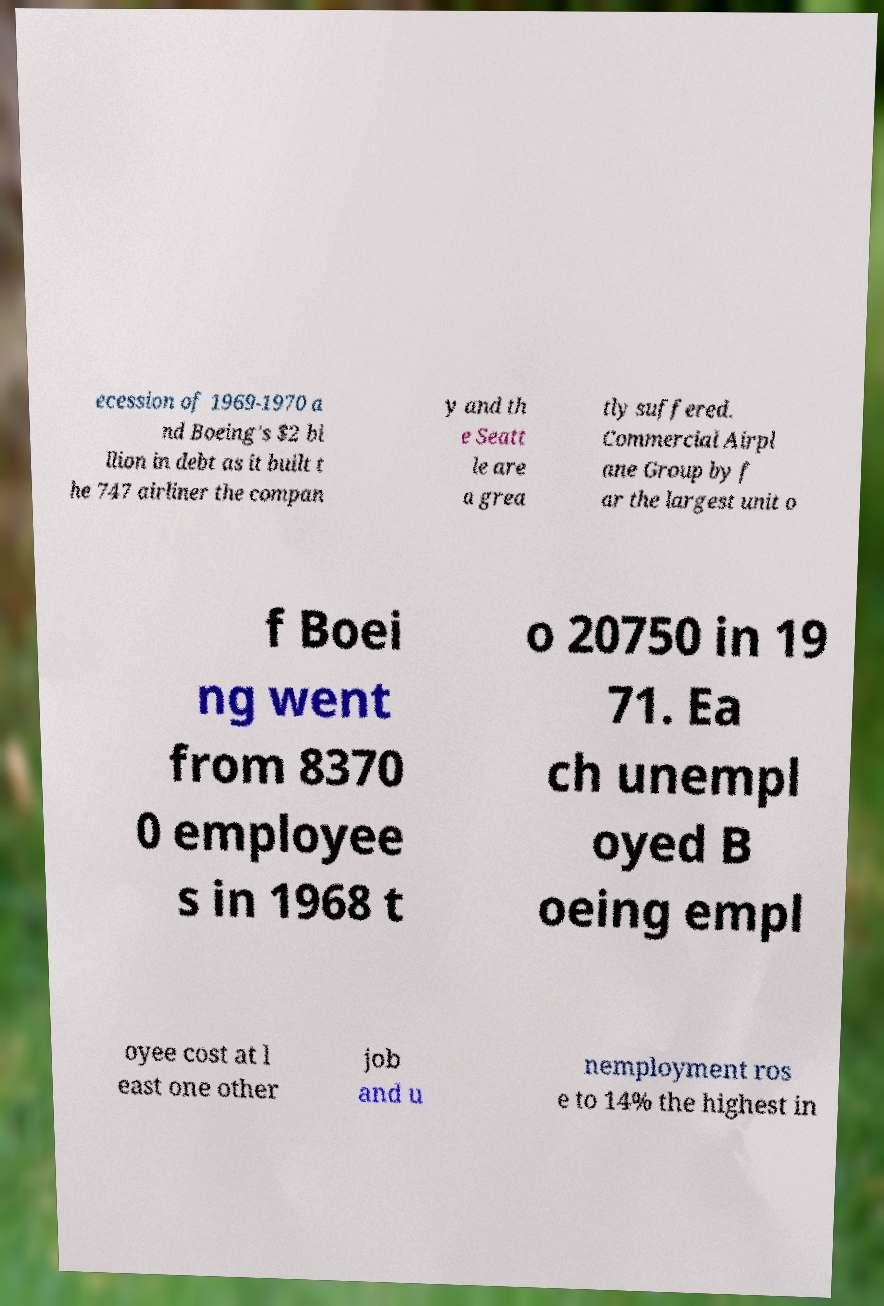Can you read and provide the text displayed in the image?This photo seems to have some interesting text. Can you extract and type it out for me? ecession of 1969-1970 a nd Boeing's $2 bi llion in debt as it built t he 747 airliner the compan y and th e Seatt le are a grea tly suffered. Commercial Airpl ane Group by f ar the largest unit o f Boei ng went from 8370 0 employee s in 1968 t o 20750 in 19 71. Ea ch unempl oyed B oeing empl oyee cost at l east one other job and u nemployment ros e to 14% the highest in 